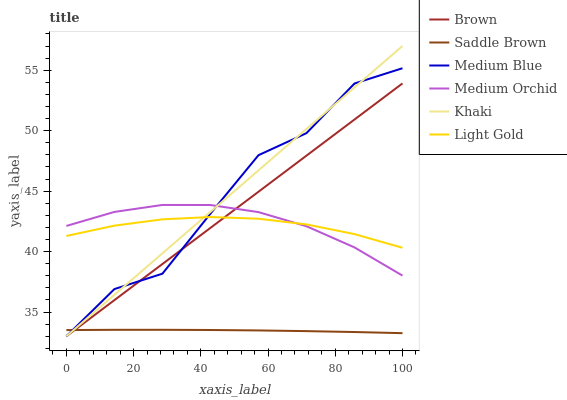Does Medium Orchid have the minimum area under the curve?
Answer yes or no. No. Does Medium Orchid have the maximum area under the curve?
Answer yes or no. No. Is Medium Orchid the smoothest?
Answer yes or no. No. Is Medium Orchid the roughest?
Answer yes or no. No. Does Medium Orchid have the lowest value?
Answer yes or no. No. Does Medium Orchid have the highest value?
Answer yes or no. No. Is Saddle Brown less than Light Gold?
Answer yes or no. Yes. Is Medium Orchid greater than Saddle Brown?
Answer yes or no. Yes. Does Saddle Brown intersect Light Gold?
Answer yes or no. No. 